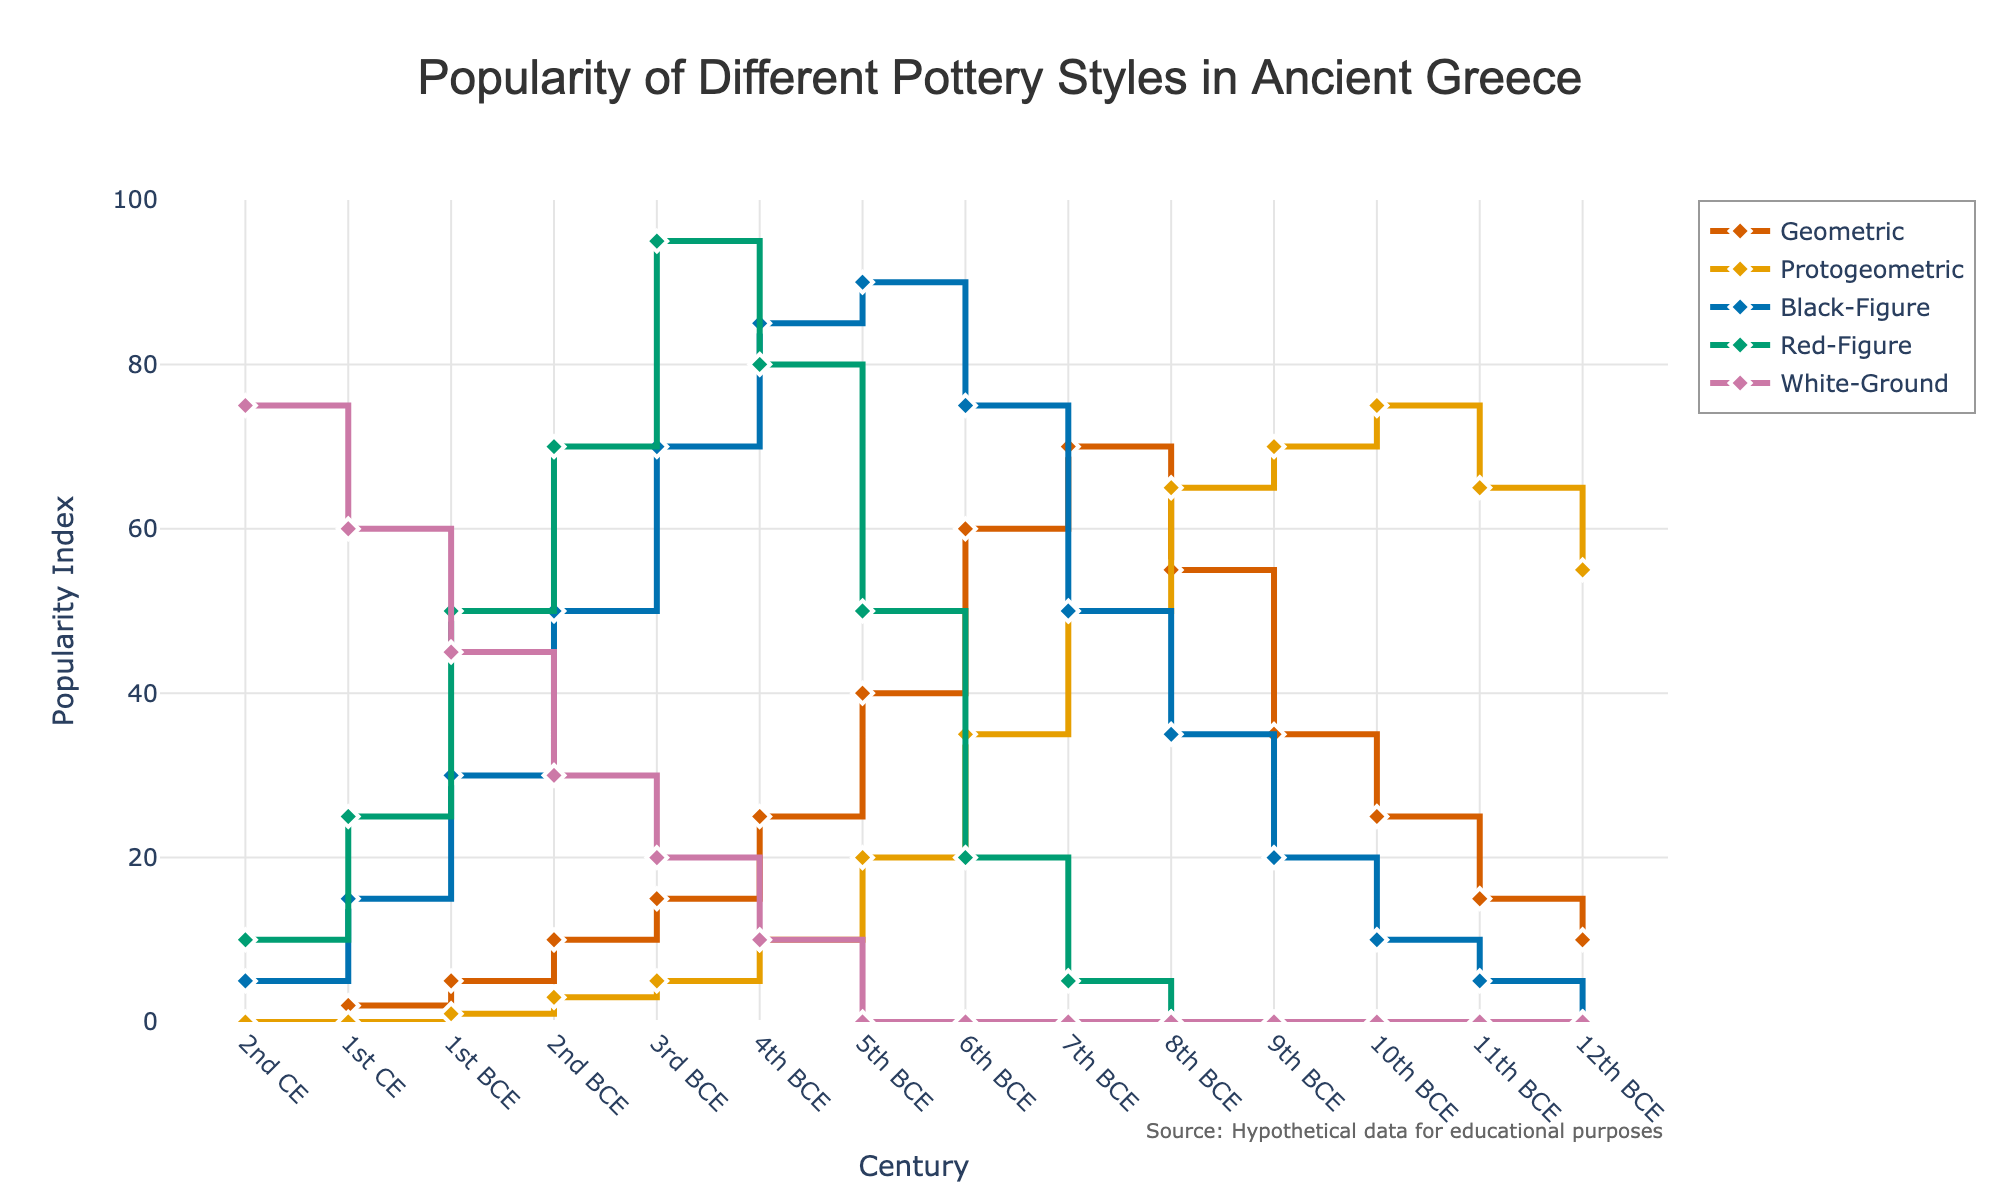What is the title of the figure? The title of the figure is usually displayed prominently at the top, often in a larger or bold font to make it stand out. In this case, the figure title appears at the top center.
Answer: Popularity of Different Pottery Styles in Ancient Greece Which pottery style had the highest popularity index in the 9th century BCE? To find this, look at the data point for each pottery style at the 9th century BCE position. Compare all the values and identify the largest one.
Answer: Protogeometric How did the popularity of the Geometric style change from the 12th century BCE to the 1st CE? Look at the popularity values of the Geometric style at the 12th century BCE and 1st CE points on the x-axis and compare them.
Answer: Decreased Which style became popular starting only from the 5th century BCE? Observing the x-axis from the 1st CE back to see when each line starts above zero, noting that Red-Figure and White-Ground start showing values significantly later.
Answer: White-Ground What is the general trend of the Black-Figure style over the centuries? Identify the values for the Black-Figure style across all centuries, then describe whether they generally rise, fall, or stay consistent.
Answer: Increase then decrease Which century shows the maximum popularity for the Red-Figure pottery style? Locate the peak value point on the line representing the Red-Figure style and note the corresponding century on the x-axis.
Answer: 3rd BCE When did the Protogeometric style reach its peak popularity? Find the highest data point on the Protogeometric line and trace it back to the corresponding century.
Answer: 10th BCE What can be said about the popularity of the White-Ground style in the 2nd century CE? Look specifically at the 2nd century CE data point for White-Ground and note its popularity value compared to other styles at that century.
Answer: It was the most popular Which styles were equally popular in the 2nd century BCE? Compare the data points of all pottery styles in the 2nd century BCE to find if any two or more lines cross or have the same value at that point.
Answer: None What is the difference in popularity between the Geometric and Red-Figure styles in the 6th century BCE? Subtract the popularity index of the Red-Figure style from the Geometric style at the 6th century BCE point.
Answer: 40 